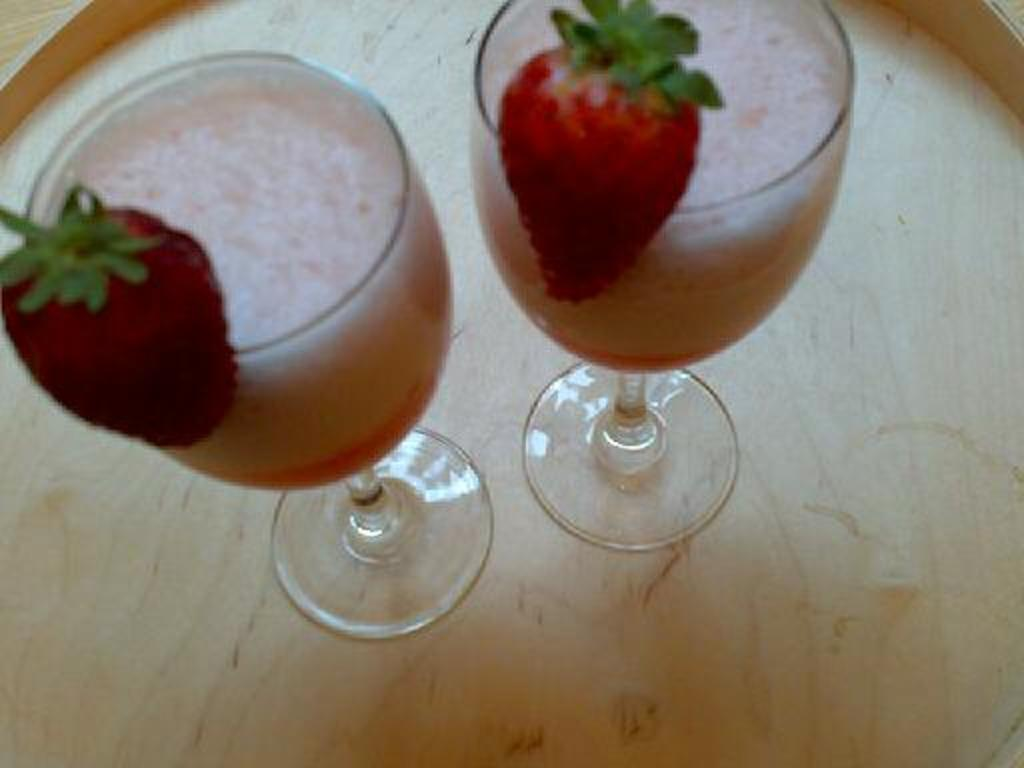What is in the glasses that are visible in the image? There are two glasses of juice in the image. What is added to the juice in the glasses? The glasses of juice have strawberries in them. Where are the glasses of juice with strawberries located? The glasses of juice with strawberries are placed on a table. What type of weather can be seen in the image? There is no weather visible in the image, as it focuses on the glasses of juice with strawberries on a table. 